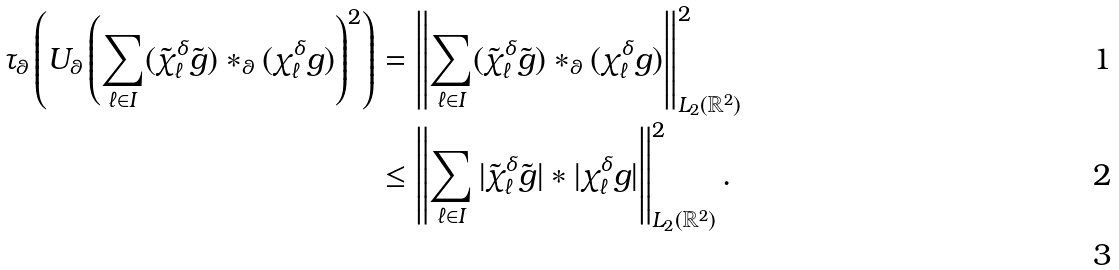Convert formula to latex. <formula><loc_0><loc_0><loc_500><loc_500>\tau _ { \theta } \left ( U _ { \theta } \left ( \sum _ { \ell \in I } ( \tilde { \chi } _ { \ell } ^ { \delta } \tilde { g } ) * _ { \theta } ( \chi _ { \ell } ^ { \delta } g ) \right ) ^ { 2 } \right ) & = \left \| \sum _ { \ell \in I } ( \tilde { \chi } _ { \ell } ^ { \delta } \tilde { g } ) * _ { \theta } ( \chi _ { \ell } ^ { \delta } g ) \right \| _ { L _ { 2 } ( \mathbb { R } ^ { 2 } ) } ^ { 2 } \\ & \leq \left \| \sum _ { \ell \in I } | \tilde { \chi } _ { \ell } ^ { \delta } \tilde { g } | * | \chi _ { \ell } ^ { \delta } g | \right \| _ { L _ { 2 } ( \mathbb { R } ^ { 2 } ) } ^ { 2 } . \\</formula> 